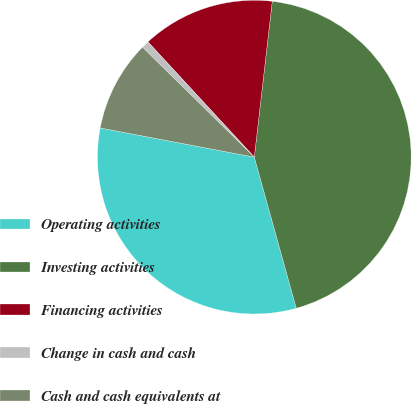<chart> <loc_0><loc_0><loc_500><loc_500><pie_chart><fcel>Operating activities<fcel>Investing activities<fcel>Financing activities<fcel>Change in cash and cash<fcel>Cash and cash equivalents at<nl><fcel>32.29%<fcel>43.86%<fcel>13.69%<fcel>0.77%<fcel>9.39%<nl></chart> 